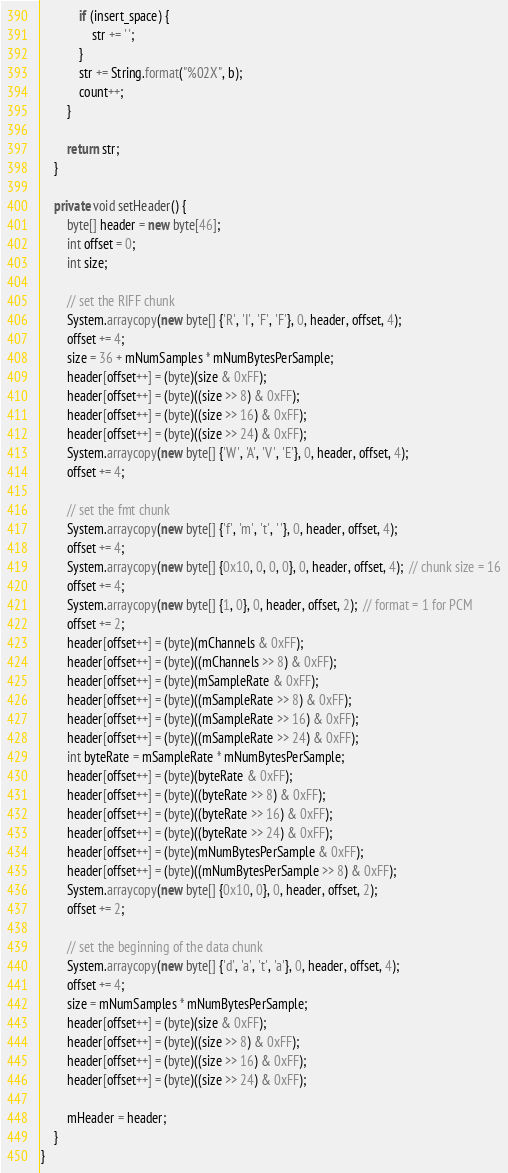<code> <loc_0><loc_0><loc_500><loc_500><_Java_>            if (insert_space) {
                str += ' ';
            }
            str += String.format("%02X", b);
            count++;
        }

        return str;
    }

    private void setHeader() {
        byte[] header = new byte[46];
        int offset = 0;
        int size;

        // set the RIFF chunk
        System.arraycopy(new byte[] {'R', 'I', 'F', 'F'}, 0, header, offset, 4);
        offset += 4;
        size = 36 + mNumSamples * mNumBytesPerSample;
        header[offset++] = (byte)(size & 0xFF);
        header[offset++] = (byte)((size >> 8) & 0xFF);
        header[offset++] = (byte)((size >> 16) & 0xFF);
        header[offset++] = (byte)((size >> 24) & 0xFF);
        System.arraycopy(new byte[] {'W', 'A', 'V', 'E'}, 0, header, offset, 4);
        offset += 4;

        // set the fmt chunk
        System.arraycopy(new byte[] {'f', 'm', 't', ' '}, 0, header, offset, 4);
        offset += 4;
        System.arraycopy(new byte[] {0x10, 0, 0, 0}, 0, header, offset, 4);  // chunk size = 16
        offset += 4;
        System.arraycopy(new byte[] {1, 0}, 0, header, offset, 2);  // format = 1 for PCM
        offset += 2;
        header[offset++] = (byte)(mChannels & 0xFF);
        header[offset++] = (byte)((mChannels >> 8) & 0xFF);
        header[offset++] = (byte)(mSampleRate & 0xFF);
        header[offset++] = (byte)((mSampleRate >> 8) & 0xFF);
        header[offset++] = (byte)((mSampleRate >> 16) & 0xFF);
        header[offset++] = (byte)((mSampleRate >> 24) & 0xFF);
        int byteRate = mSampleRate * mNumBytesPerSample;
        header[offset++] = (byte)(byteRate & 0xFF);
        header[offset++] = (byte)((byteRate >> 8) & 0xFF);
        header[offset++] = (byte)((byteRate >> 16) & 0xFF);
        header[offset++] = (byte)((byteRate >> 24) & 0xFF);
        header[offset++] = (byte)(mNumBytesPerSample & 0xFF);
        header[offset++] = (byte)((mNumBytesPerSample >> 8) & 0xFF);
        System.arraycopy(new byte[] {0x10, 0}, 0, header, offset, 2);
        offset += 2;

        // set the beginning of the data chunk
        System.arraycopy(new byte[] {'d', 'a', 't', 'a'}, 0, header, offset, 4);
        offset += 4;
        size = mNumSamples * mNumBytesPerSample;
        header[offset++] = (byte)(size & 0xFF);
        header[offset++] = (byte)((size >> 8) & 0xFF);
        header[offset++] = (byte)((size >> 16) & 0xFF);
        header[offset++] = (byte)((size >> 24) & 0xFF);

        mHeader = header;
    }
}
</code> 